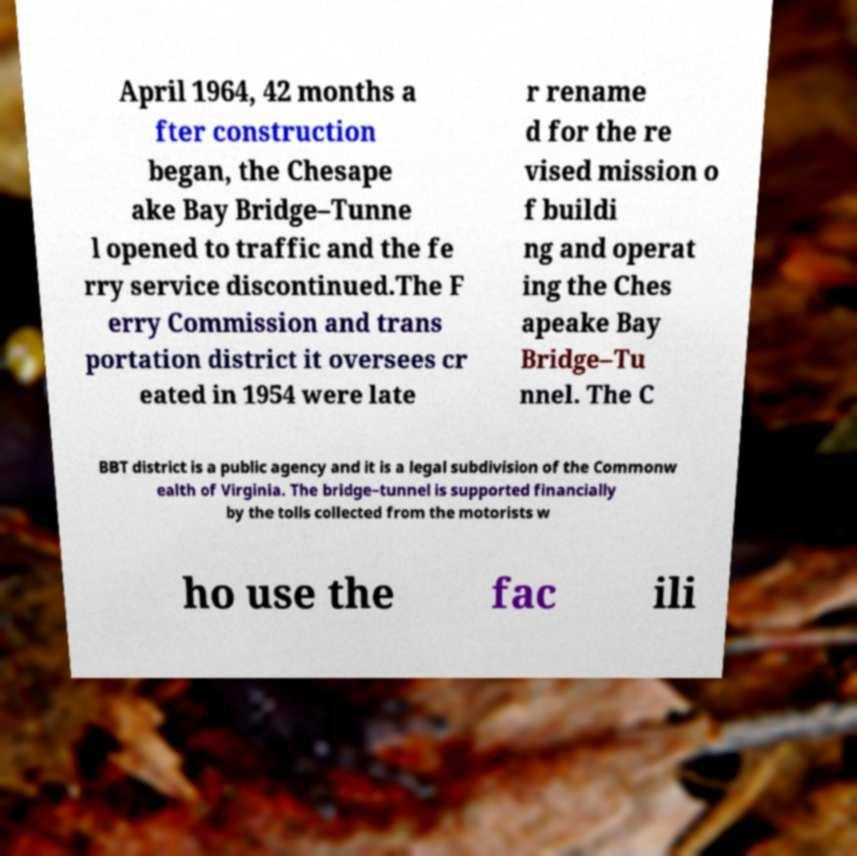Could you extract and type out the text from this image? April 1964, 42 months a fter construction began, the Chesape ake Bay Bridge–Tunne l opened to traffic and the fe rry service discontinued.The F erry Commission and trans portation district it oversees cr eated in 1954 were late r rename d for the re vised mission o f buildi ng and operat ing the Ches apeake Bay Bridge–Tu nnel. The C BBT district is a public agency and it is a legal subdivision of the Commonw ealth of Virginia. The bridge–tunnel is supported financially by the tolls collected from the motorists w ho use the fac ili 